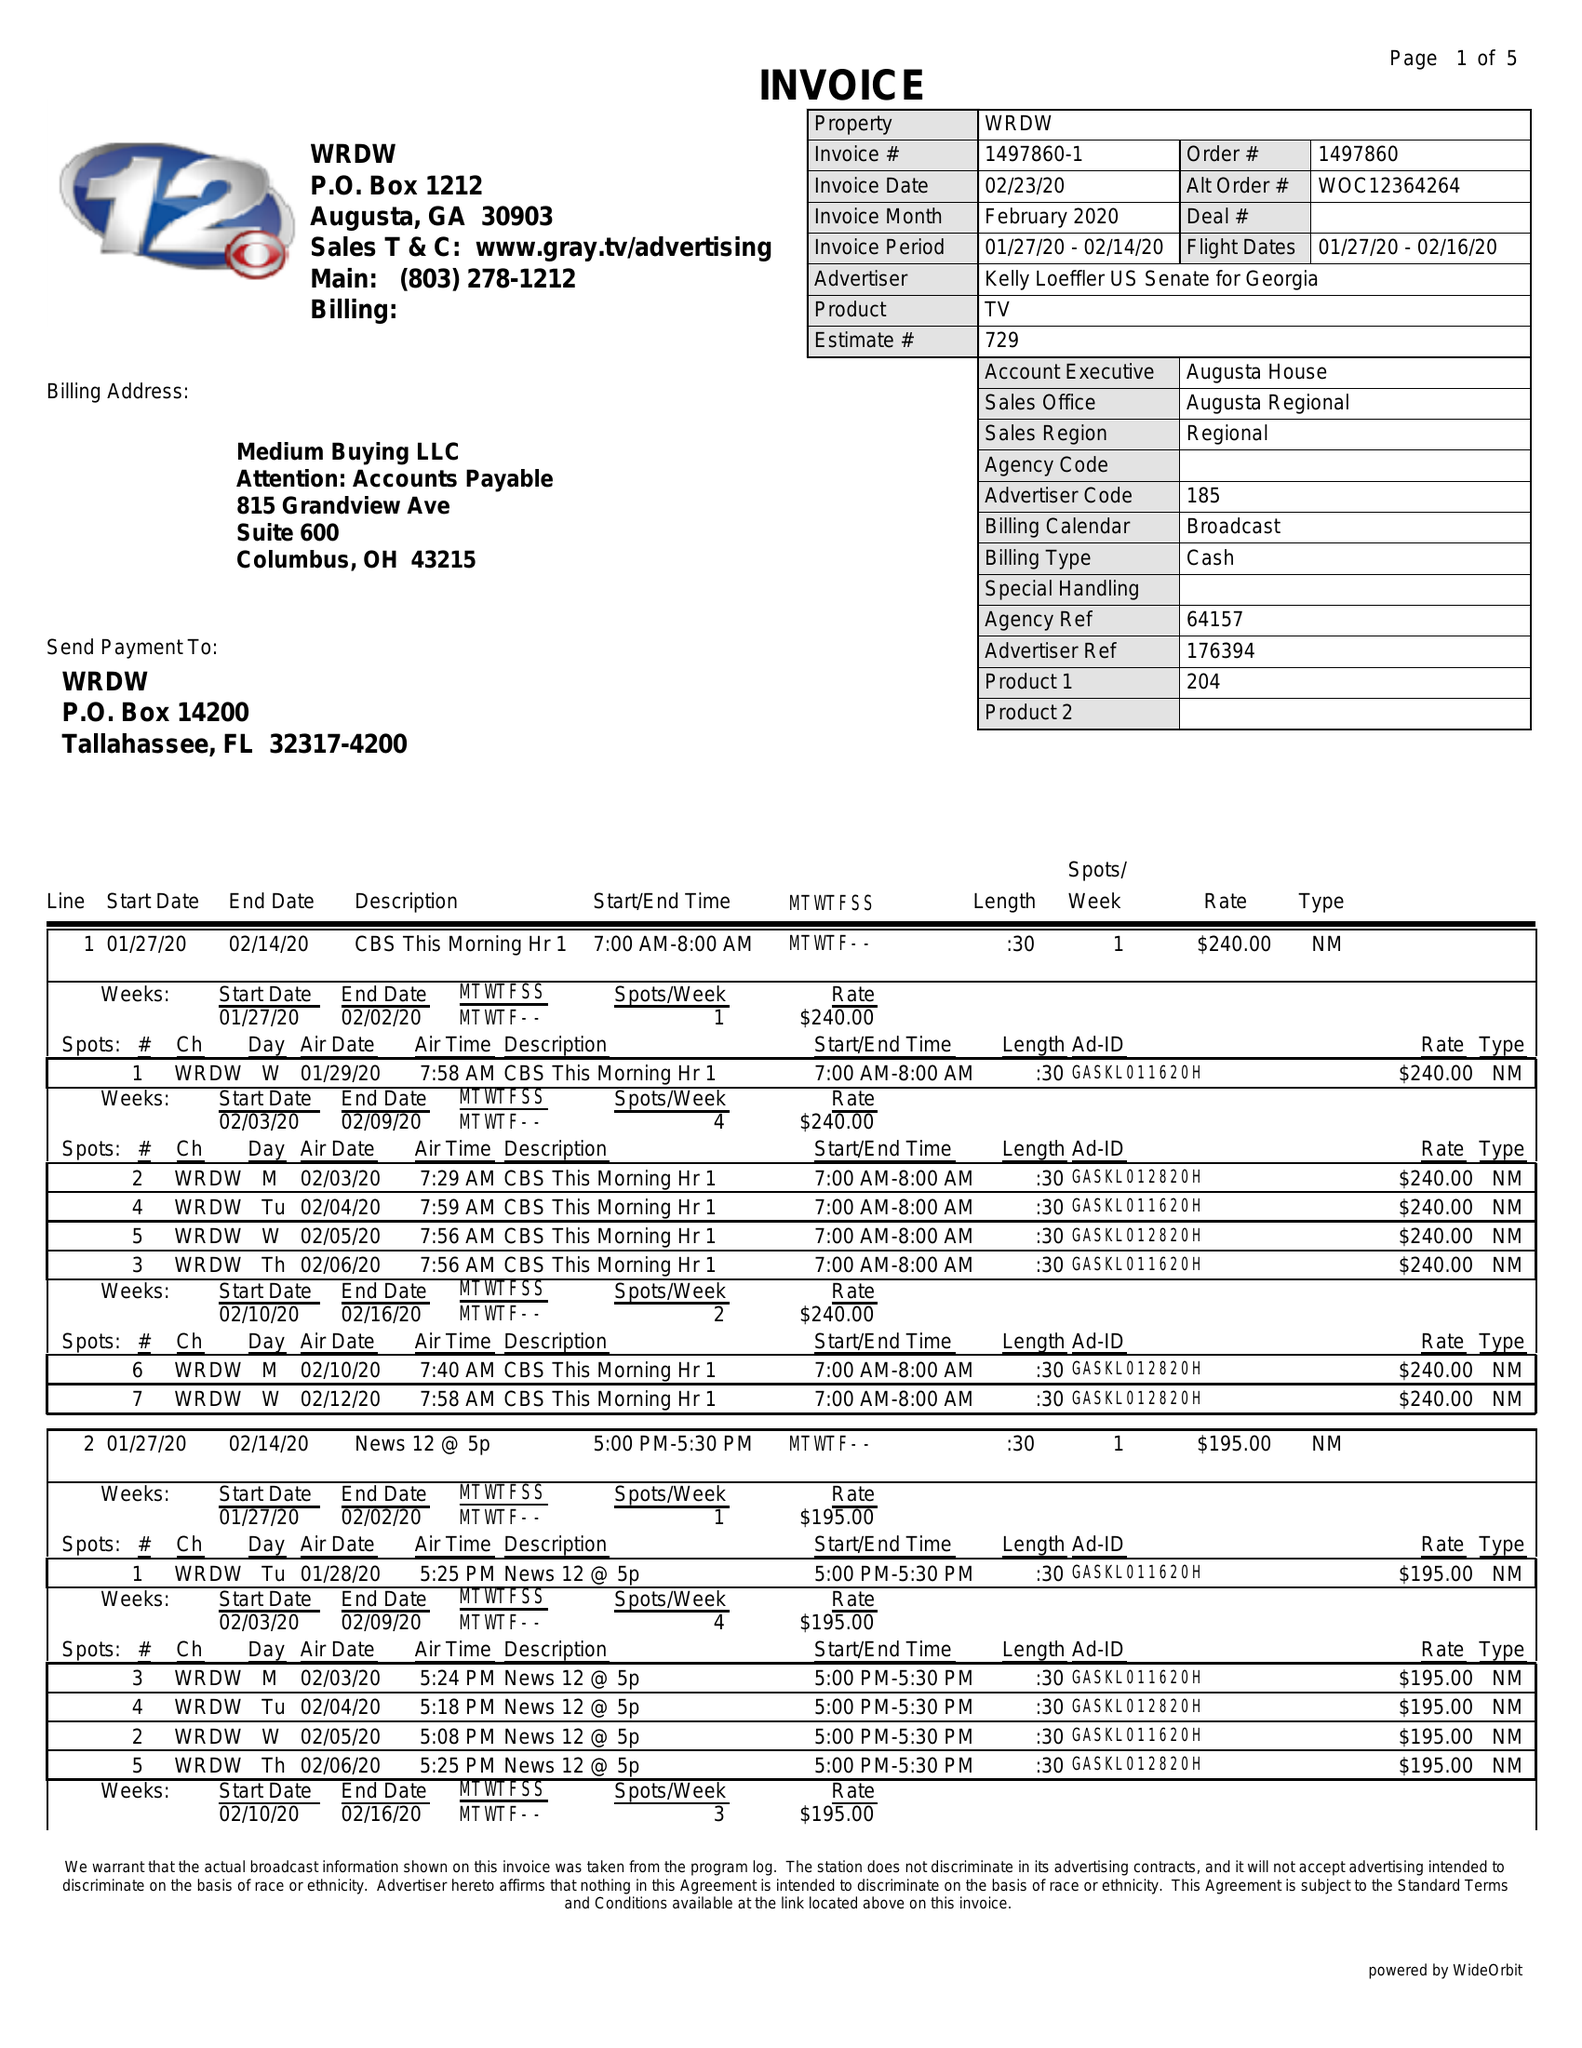What is the value for the advertiser?
Answer the question using a single word or phrase. KELLY LOEFFLER US SENATE FOR GEORGIA 